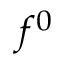Convert formula to latex. <formula><loc_0><loc_0><loc_500><loc_500>f ^ { 0 }</formula> 